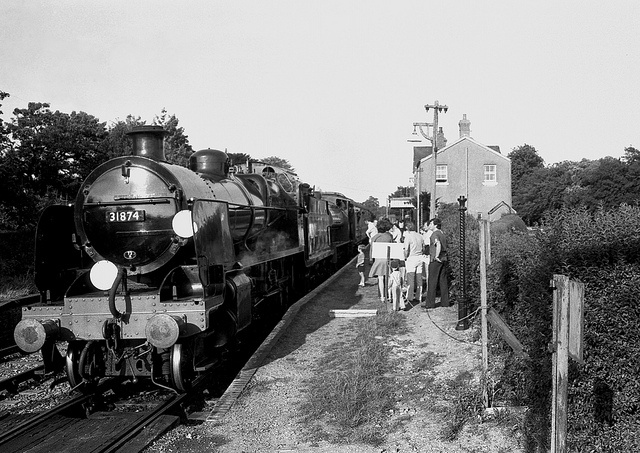Describe the objects in this image and their specific colors. I can see train in lightgray, black, gray, and darkgray tones, people in lightgray, black, gray, gainsboro, and darkgray tones, people in lightgray, darkgray, gray, and black tones, people in lightgray, gray, darkgray, and black tones, and people in lightgray, gray, darkgray, and black tones in this image. 